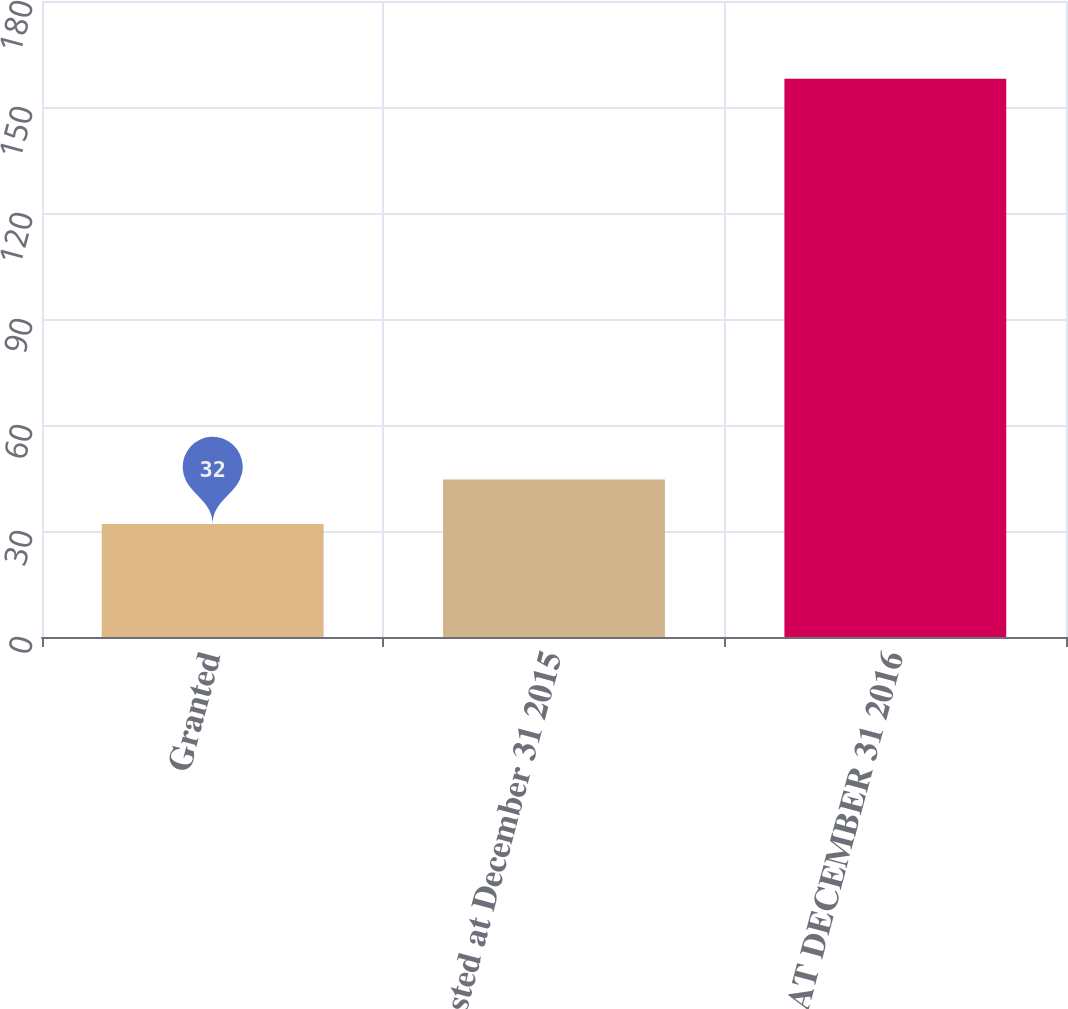<chart> <loc_0><loc_0><loc_500><loc_500><bar_chart><fcel>Granted<fcel>Nonvested at December 31 2015<fcel>NONVESTED AT DECEMBER 31 2016<nl><fcel>32<fcel>44.6<fcel>158<nl></chart> 